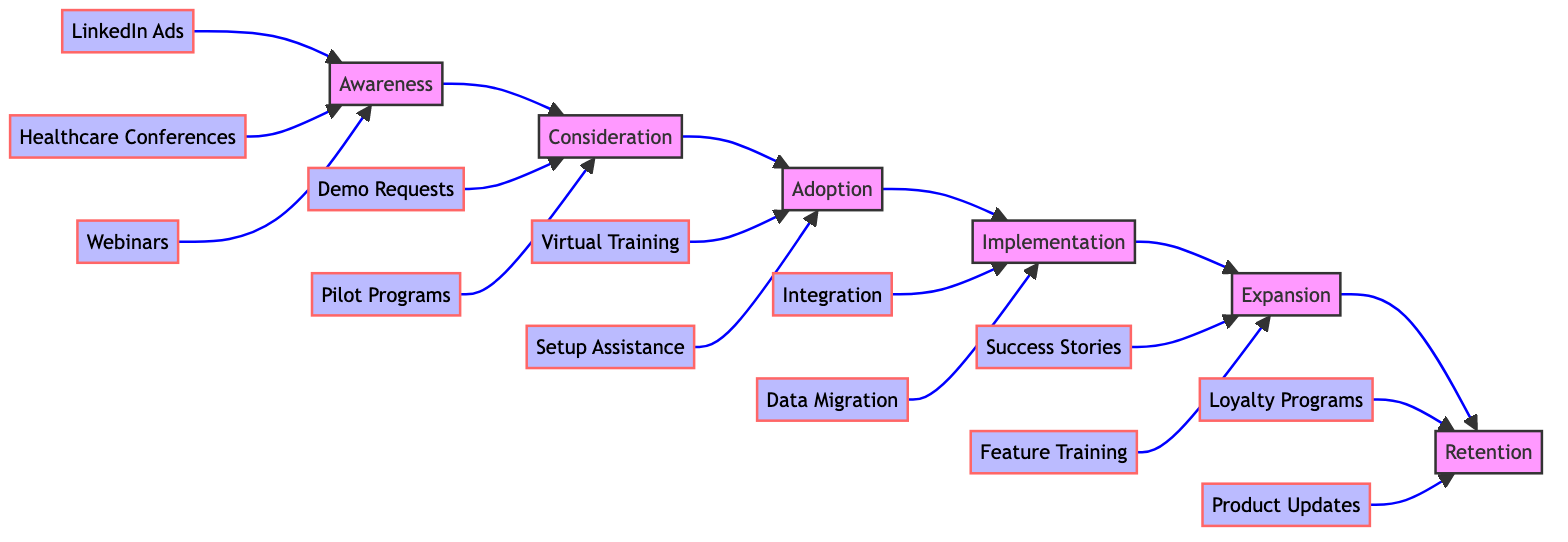What are the three marketing channels in the Awareness phase? In the diagram, the Awareness phase has three marketing channels listed: LinkedIn Ads, Healthcare Conferences, and Medical Journals. These are displayed as nodes connected to the Awareness phase.
Answer: LinkedIn Ads, Healthcare Conferences, Medical Journals How many key activities are defined in the Consideration phase? The Consideration phase includes two key activities: Consultations with Healthcare Providers and Pilot Program Enrollments. This is observed where these activities are listed under the Consideration node.
Answer: 2 What is the next phase after Adoption? The diagram shows a clear flow from the Adoption phase to the Implementation phase. The arrow connecting these two phases indicates this sequential relationship.
Answer: Implementation Which activity in the Expansion phase focuses on ongoing customer interaction? The activity that emphasizes ongoing interaction with customers in the Expansion phase is Regular Check-ins. This is confirmed by examining the activities listed under the Expansion node.
Answer: Regular Check-ins What are the two customer onboarding methods mentioned in the Adoption phase? In the Adoption phase, the two customer onboarding methods specified are Virtual Training Sessions and User Manuals. These are presented as nodes branching from the Adoption phase.
Answer: Virtual Training Sessions, User Manuals How many customer support activities are listed in the Implementation phase? There are two customer support activities listed in the Implementation phase: Dedicated Account Manager and Integration with Existing Systems. This can be verified by counting the support activities under the Implementation node.
Answer: 2 What is the customer loyalty focus in the Retention phase? The primary focus on customer loyalty in the Retention phase is expressed through Loyalty Programs, which is one of the activities linked to the Retention node.
Answer: Loyalty Programs What activities are involved in the Consideration phase? The activities in the Consideration phase include Demo Requests, Customer Testimonials, and Comparative Studies. All three activities are directly connected to the Consideration node in the diagram.
Answer: Demo Requests, Customer Testimonials, Comparative Studies What type of process is represented by this diagram? This diagram represents a Clinical Pathway which maps the stages and activities involved in the Customer Journey of Healthtech Product Adoption. Each phase showcases a series of transitions completed by various activities.
Answer: Clinical Pathway 